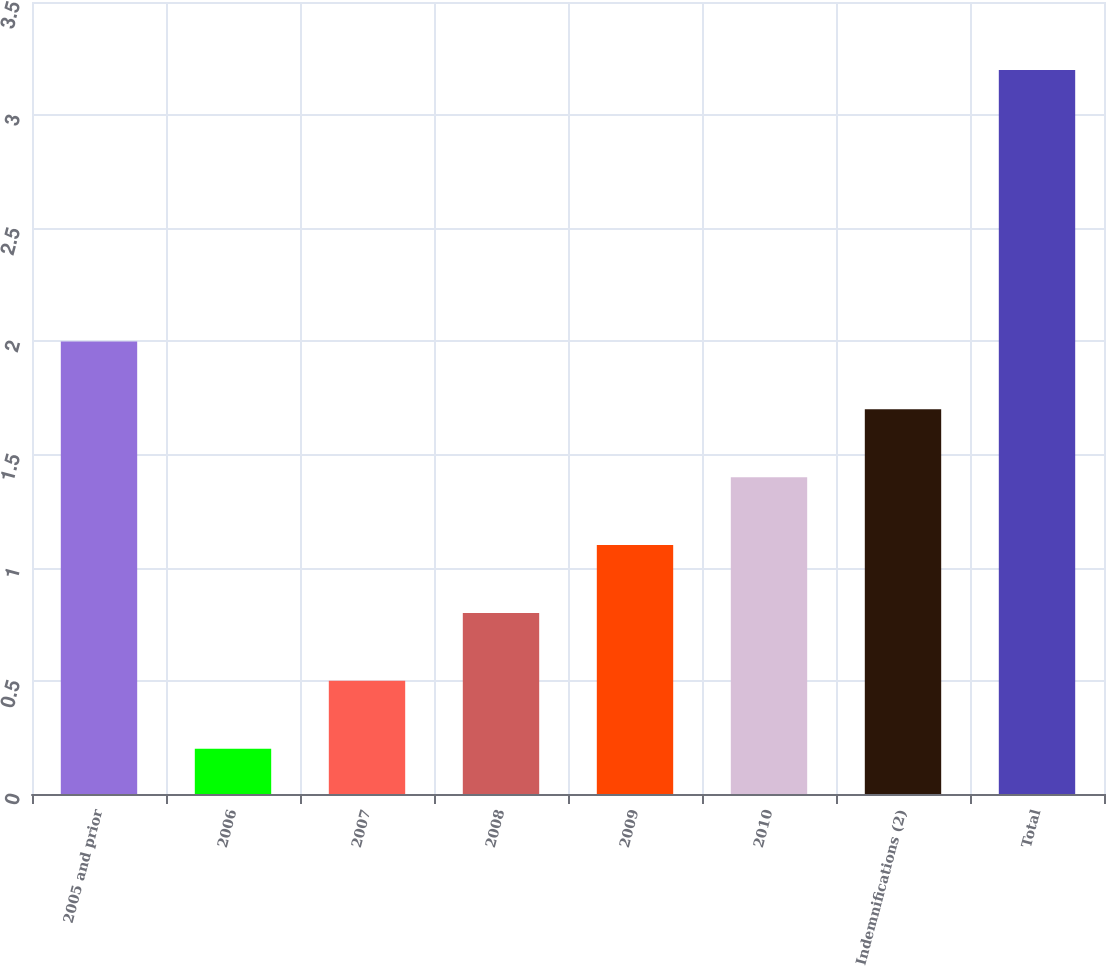<chart> <loc_0><loc_0><loc_500><loc_500><bar_chart><fcel>2005 and prior<fcel>2006<fcel>2007<fcel>2008<fcel>2009<fcel>2010<fcel>Indemnifications (2)<fcel>Total<nl><fcel>2<fcel>0.2<fcel>0.5<fcel>0.8<fcel>1.1<fcel>1.4<fcel>1.7<fcel>3.2<nl></chart> 